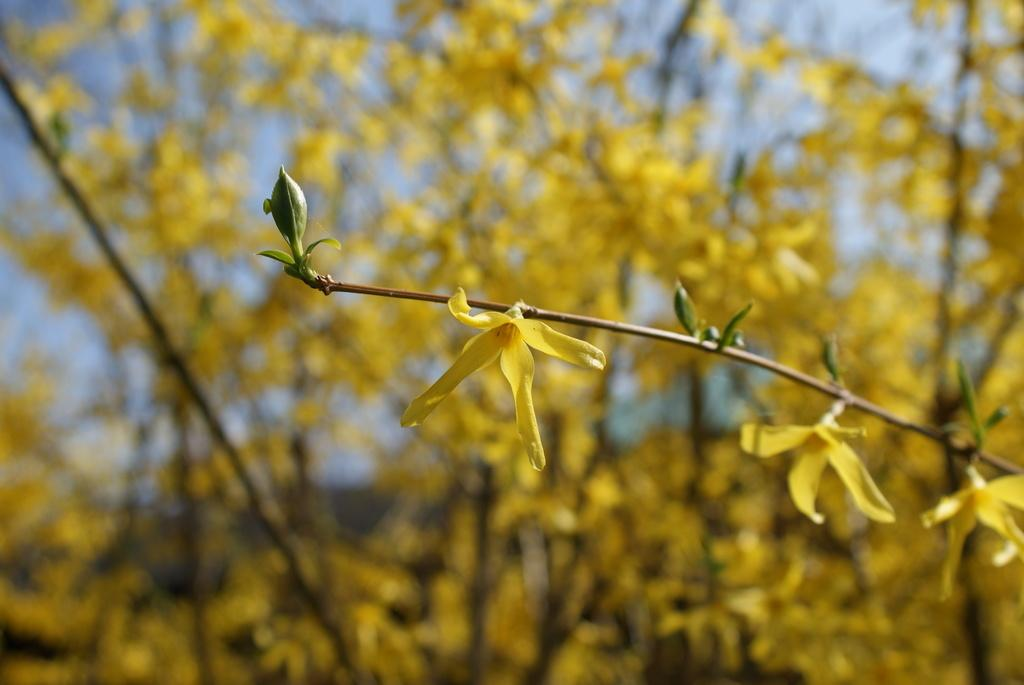What type of plants can be seen in the image? There are flowers in the image. What part of the flowers is visible in the image? There are stems in the image. What can be seen in the background of the image? The sky is visible in the background of the image. Where is the goat located in the image? There is no goat present in the image. What type of patch is visible on the flowers in the image? There is no patch visible on the flowers in the image. 